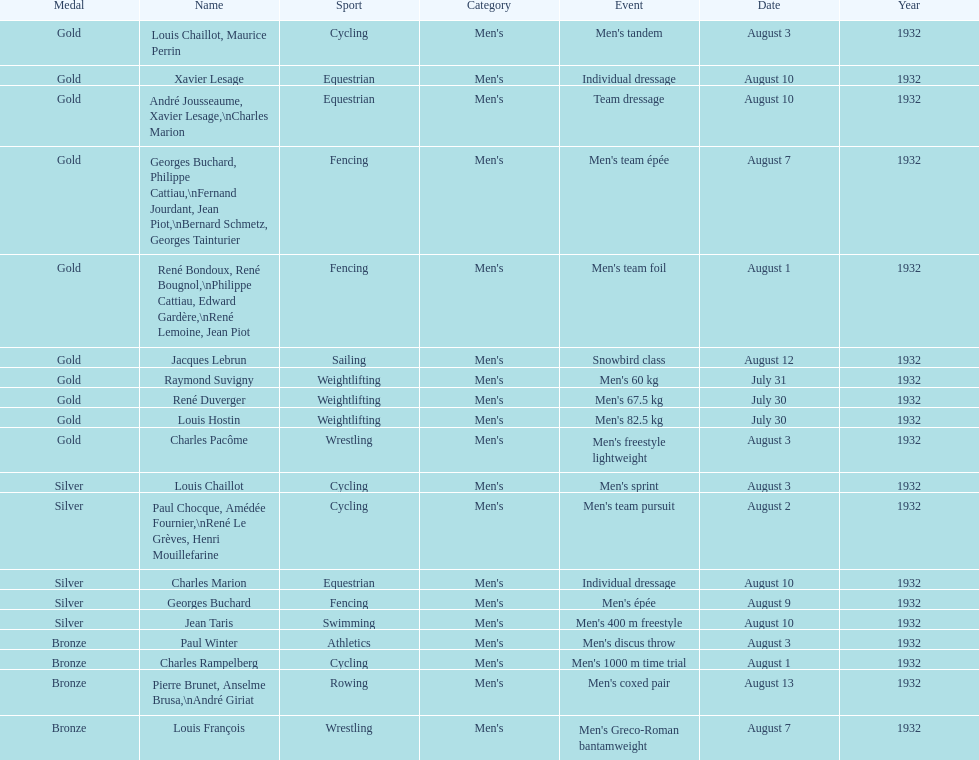Was there more gold medals won than silver? Yes. 